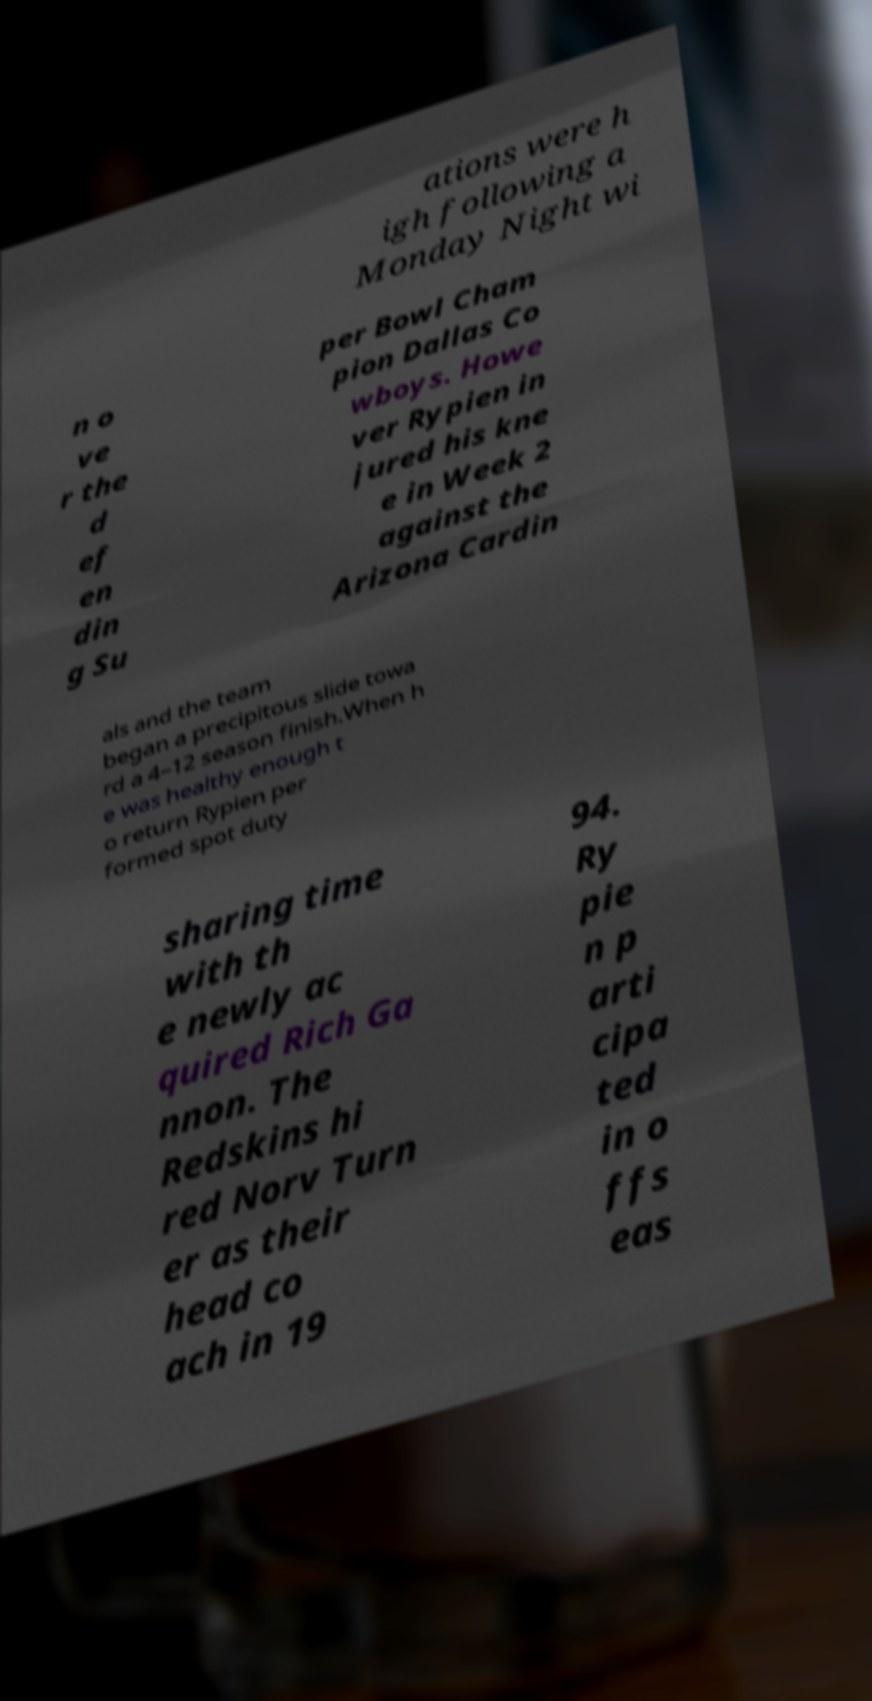Please read and relay the text visible in this image. What does it say? ations were h igh following a Monday Night wi n o ve r the d ef en din g Su per Bowl Cham pion Dallas Co wboys. Howe ver Rypien in jured his kne e in Week 2 against the Arizona Cardin als and the team began a precipitous slide towa rd a 4–12 season finish.When h e was healthy enough t o return Rypien per formed spot duty sharing time with th e newly ac quired Rich Ga nnon. The Redskins hi red Norv Turn er as their head co ach in 19 94. Ry pie n p arti cipa ted in o ffs eas 